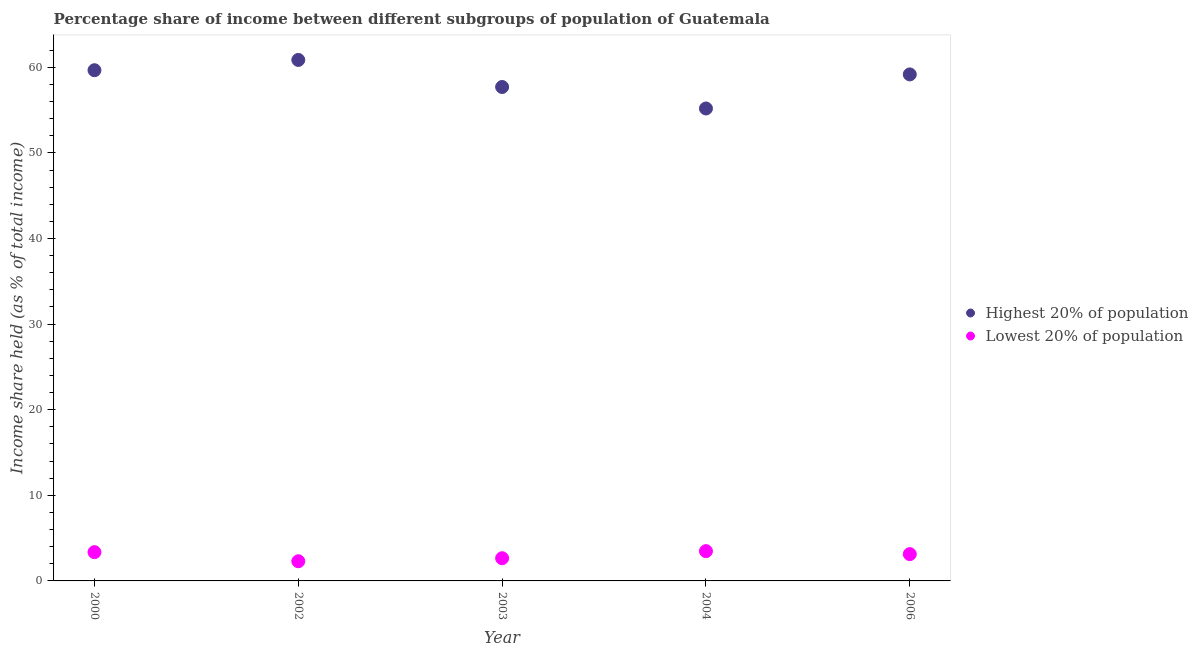What is the income share held by lowest 20% of the population in 2006?
Keep it short and to the point. 3.13. Across all years, what is the maximum income share held by highest 20% of the population?
Provide a succinct answer. 60.86. Across all years, what is the minimum income share held by highest 20% of the population?
Ensure brevity in your answer.  55.19. What is the total income share held by highest 20% of the population in the graph?
Provide a short and direct response. 292.58. What is the difference between the income share held by highest 20% of the population in 2000 and that in 2002?
Offer a very short reply. -1.2. What is the difference between the income share held by lowest 20% of the population in 2006 and the income share held by highest 20% of the population in 2000?
Provide a succinct answer. -56.53. What is the average income share held by highest 20% of the population per year?
Keep it short and to the point. 58.52. In the year 2003, what is the difference between the income share held by lowest 20% of the population and income share held by highest 20% of the population?
Keep it short and to the point. -55.05. In how many years, is the income share held by lowest 20% of the population greater than 24 %?
Offer a terse response. 0. What is the ratio of the income share held by highest 20% of the population in 2002 to that in 2004?
Offer a terse response. 1.1. Is the income share held by highest 20% of the population in 2000 less than that in 2003?
Your answer should be compact. No. What is the difference between the highest and the second highest income share held by lowest 20% of the population?
Your answer should be compact. 0.12. What is the difference between the highest and the lowest income share held by lowest 20% of the population?
Keep it short and to the point. 1.18. Is the sum of the income share held by lowest 20% of the population in 2000 and 2006 greater than the maximum income share held by highest 20% of the population across all years?
Ensure brevity in your answer.  No. Is the income share held by lowest 20% of the population strictly greater than the income share held by highest 20% of the population over the years?
Give a very brief answer. No. How many years are there in the graph?
Offer a very short reply. 5. What is the difference between two consecutive major ticks on the Y-axis?
Provide a succinct answer. 10. Are the values on the major ticks of Y-axis written in scientific E-notation?
Provide a short and direct response. No. Does the graph contain any zero values?
Provide a succinct answer. No. How are the legend labels stacked?
Offer a very short reply. Vertical. What is the title of the graph?
Make the answer very short. Percentage share of income between different subgroups of population of Guatemala. Does "National Tourists" appear as one of the legend labels in the graph?
Keep it short and to the point. No. What is the label or title of the Y-axis?
Keep it short and to the point. Income share held (as % of total income). What is the Income share held (as % of total income) of Highest 20% of population in 2000?
Give a very brief answer. 59.66. What is the Income share held (as % of total income) in Lowest 20% of population in 2000?
Offer a very short reply. 3.36. What is the Income share held (as % of total income) of Highest 20% of population in 2002?
Provide a succinct answer. 60.86. What is the Income share held (as % of total income) of Lowest 20% of population in 2002?
Provide a succinct answer. 2.3. What is the Income share held (as % of total income) of Highest 20% of population in 2003?
Offer a very short reply. 57.7. What is the Income share held (as % of total income) in Lowest 20% of population in 2003?
Offer a terse response. 2.65. What is the Income share held (as % of total income) of Highest 20% of population in 2004?
Your answer should be compact. 55.19. What is the Income share held (as % of total income) of Lowest 20% of population in 2004?
Make the answer very short. 3.48. What is the Income share held (as % of total income) in Highest 20% of population in 2006?
Give a very brief answer. 59.17. What is the Income share held (as % of total income) of Lowest 20% of population in 2006?
Offer a very short reply. 3.13. Across all years, what is the maximum Income share held (as % of total income) in Highest 20% of population?
Offer a very short reply. 60.86. Across all years, what is the maximum Income share held (as % of total income) of Lowest 20% of population?
Give a very brief answer. 3.48. Across all years, what is the minimum Income share held (as % of total income) of Highest 20% of population?
Offer a very short reply. 55.19. Across all years, what is the minimum Income share held (as % of total income) in Lowest 20% of population?
Your answer should be very brief. 2.3. What is the total Income share held (as % of total income) in Highest 20% of population in the graph?
Give a very brief answer. 292.58. What is the total Income share held (as % of total income) in Lowest 20% of population in the graph?
Offer a very short reply. 14.92. What is the difference between the Income share held (as % of total income) in Lowest 20% of population in 2000 and that in 2002?
Provide a succinct answer. 1.06. What is the difference between the Income share held (as % of total income) in Highest 20% of population in 2000 and that in 2003?
Offer a very short reply. 1.96. What is the difference between the Income share held (as % of total income) of Lowest 20% of population in 2000 and that in 2003?
Ensure brevity in your answer.  0.71. What is the difference between the Income share held (as % of total income) of Highest 20% of population in 2000 and that in 2004?
Offer a very short reply. 4.47. What is the difference between the Income share held (as % of total income) of Lowest 20% of population in 2000 and that in 2004?
Give a very brief answer. -0.12. What is the difference between the Income share held (as % of total income) in Highest 20% of population in 2000 and that in 2006?
Offer a very short reply. 0.49. What is the difference between the Income share held (as % of total income) in Lowest 20% of population in 2000 and that in 2006?
Ensure brevity in your answer.  0.23. What is the difference between the Income share held (as % of total income) of Highest 20% of population in 2002 and that in 2003?
Ensure brevity in your answer.  3.16. What is the difference between the Income share held (as % of total income) of Lowest 20% of population in 2002 and that in 2003?
Keep it short and to the point. -0.35. What is the difference between the Income share held (as % of total income) in Highest 20% of population in 2002 and that in 2004?
Give a very brief answer. 5.67. What is the difference between the Income share held (as % of total income) of Lowest 20% of population in 2002 and that in 2004?
Give a very brief answer. -1.18. What is the difference between the Income share held (as % of total income) of Highest 20% of population in 2002 and that in 2006?
Keep it short and to the point. 1.69. What is the difference between the Income share held (as % of total income) of Lowest 20% of population in 2002 and that in 2006?
Offer a very short reply. -0.83. What is the difference between the Income share held (as % of total income) of Highest 20% of population in 2003 and that in 2004?
Make the answer very short. 2.51. What is the difference between the Income share held (as % of total income) in Lowest 20% of population in 2003 and that in 2004?
Provide a short and direct response. -0.83. What is the difference between the Income share held (as % of total income) in Highest 20% of population in 2003 and that in 2006?
Your answer should be very brief. -1.47. What is the difference between the Income share held (as % of total income) of Lowest 20% of population in 2003 and that in 2006?
Give a very brief answer. -0.48. What is the difference between the Income share held (as % of total income) in Highest 20% of population in 2004 and that in 2006?
Give a very brief answer. -3.98. What is the difference between the Income share held (as % of total income) of Highest 20% of population in 2000 and the Income share held (as % of total income) of Lowest 20% of population in 2002?
Your answer should be very brief. 57.36. What is the difference between the Income share held (as % of total income) in Highest 20% of population in 2000 and the Income share held (as % of total income) in Lowest 20% of population in 2003?
Offer a very short reply. 57.01. What is the difference between the Income share held (as % of total income) of Highest 20% of population in 2000 and the Income share held (as % of total income) of Lowest 20% of population in 2004?
Your answer should be very brief. 56.18. What is the difference between the Income share held (as % of total income) of Highest 20% of population in 2000 and the Income share held (as % of total income) of Lowest 20% of population in 2006?
Offer a very short reply. 56.53. What is the difference between the Income share held (as % of total income) in Highest 20% of population in 2002 and the Income share held (as % of total income) in Lowest 20% of population in 2003?
Your response must be concise. 58.21. What is the difference between the Income share held (as % of total income) in Highest 20% of population in 2002 and the Income share held (as % of total income) in Lowest 20% of population in 2004?
Offer a very short reply. 57.38. What is the difference between the Income share held (as % of total income) in Highest 20% of population in 2002 and the Income share held (as % of total income) in Lowest 20% of population in 2006?
Ensure brevity in your answer.  57.73. What is the difference between the Income share held (as % of total income) of Highest 20% of population in 2003 and the Income share held (as % of total income) of Lowest 20% of population in 2004?
Provide a short and direct response. 54.22. What is the difference between the Income share held (as % of total income) in Highest 20% of population in 2003 and the Income share held (as % of total income) in Lowest 20% of population in 2006?
Give a very brief answer. 54.57. What is the difference between the Income share held (as % of total income) of Highest 20% of population in 2004 and the Income share held (as % of total income) of Lowest 20% of population in 2006?
Make the answer very short. 52.06. What is the average Income share held (as % of total income) in Highest 20% of population per year?
Keep it short and to the point. 58.52. What is the average Income share held (as % of total income) of Lowest 20% of population per year?
Offer a very short reply. 2.98. In the year 2000, what is the difference between the Income share held (as % of total income) of Highest 20% of population and Income share held (as % of total income) of Lowest 20% of population?
Your answer should be very brief. 56.3. In the year 2002, what is the difference between the Income share held (as % of total income) of Highest 20% of population and Income share held (as % of total income) of Lowest 20% of population?
Your answer should be very brief. 58.56. In the year 2003, what is the difference between the Income share held (as % of total income) in Highest 20% of population and Income share held (as % of total income) in Lowest 20% of population?
Offer a terse response. 55.05. In the year 2004, what is the difference between the Income share held (as % of total income) of Highest 20% of population and Income share held (as % of total income) of Lowest 20% of population?
Provide a succinct answer. 51.71. In the year 2006, what is the difference between the Income share held (as % of total income) of Highest 20% of population and Income share held (as % of total income) of Lowest 20% of population?
Give a very brief answer. 56.04. What is the ratio of the Income share held (as % of total income) of Highest 20% of population in 2000 to that in 2002?
Give a very brief answer. 0.98. What is the ratio of the Income share held (as % of total income) in Lowest 20% of population in 2000 to that in 2002?
Offer a terse response. 1.46. What is the ratio of the Income share held (as % of total income) of Highest 20% of population in 2000 to that in 2003?
Your answer should be very brief. 1.03. What is the ratio of the Income share held (as % of total income) in Lowest 20% of population in 2000 to that in 2003?
Offer a very short reply. 1.27. What is the ratio of the Income share held (as % of total income) in Highest 20% of population in 2000 to that in 2004?
Provide a short and direct response. 1.08. What is the ratio of the Income share held (as % of total income) of Lowest 20% of population in 2000 to that in 2004?
Your answer should be very brief. 0.97. What is the ratio of the Income share held (as % of total income) of Highest 20% of population in 2000 to that in 2006?
Your response must be concise. 1.01. What is the ratio of the Income share held (as % of total income) in Lowest 20% of population in 2000 to that in 2006?
Your answer should be very brief. 1.07. What is the ratio of the Income share held (as % of total income) in Highest 20% of population in 2002 to that in 2003?
Give a very brief answer. 1.05. What is the ratio of the Income share held (as % of total income) in Lowest 20% of population in 2002 to that in 2003?
Your answer should be compact. 0.87. What is the ratio of the Income share held (as % of total income) of Highest 20% of population in 2002 to that in 2004?
Your answer should be compact. 1.1. What is the ratio of the Income share held (as % of total income) of Lowest 20% of population in 2002 to that in 2004?
Ensure brevity in your answer.  0.66. What is the ratio of the Income share held (as % of total income) in Highest 20% of population in 2002 to that in 2006?
Ensure brevity in your answer.  1.03. What is the ratio of the Income share held (as % of total income) in Lowest 20% of population in 2002 to that in 2006?
Your answer should be compact. 0.73. What is the ratio of the Income share held (as % of total income) in Highest 20% of population in 2003 to that in 2004?
Make the answer very short. 1.05. What is the ratio of the Income share held (as % of total income) of Lowest 20% of population in 2003 to that in 2004?
Ensure brevity in your answer.  0.76. What is the ratio of the Income share held (as % of total income) of Highest 20% of population in 2003 to that in 2006?
Keep it short and to the point. 0.98. What is the ratio of the Income share held (as % of total income) of Lowest 20% of population in 2003 to that in 2006?
Ensure brevity in your answer.  0.85. What is the ratio of the Income share held (as % of total income) in Highest 20% of population in 2004 to that in 2006?
Ensure brevity in your answer.  0.93. What is the ratio of the Income share held (as % of total income) of Lowest 20% of population in 2004 to that in 2006?
Offer a terse response. 1.11. What is the difference between the highest and the second highest Income share held (as % of total income) of Lowest 20% of population?
Offer a terse response. 0.12. What is the difference between the highest and the lowest Income share held (as % of total income) in Highest 20% of population?
Make the answer very short. 5.67. What is the difference between the highest and the lowest Income share held (as % of total income) of Lowest 20% of population?
Your answer should be compact. 1.18. 